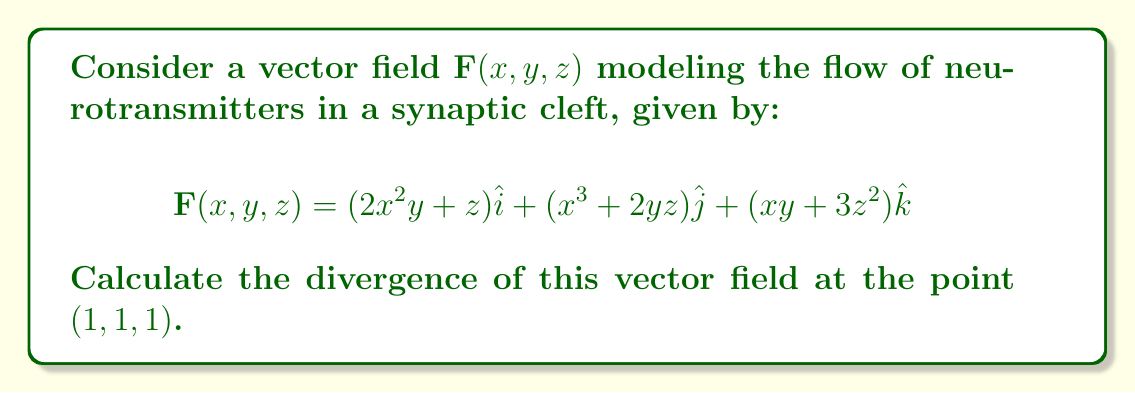Give your solution to this math problem. To calculate the divergence of the vector field $\mathbf{F}(x,y,z)$, we need to use the divergence formula in Cartesian coordinates:

$$\text{div}\,\mathbf{F} = \nabla \cdot \mathbf{F} = \frac{\partial F_x}{\partial x} + \frac{\partial F_y}{\partial y} + \frac{\partial F_z}{\partial z}$$

Let's break it down step-by-step:

1) First, identify the components of $\mathbf{F}$:
   $F_x = 2x^2y + z$
   $F_y = x^3 + 2yz$
   $F_z = xy + 3z^2$

2) Calculate the partial derivatives:
   $\frac{\partial F_x}{\partial x} = 4xy$
   $\frac{\partial F_y}{\partial y} = 2z$
   $\frac{\partial F_z}{\partial z} = 6z$

3) Sum these partial derivatives:
   $\text{div}\,\mathbf{F} = 4xy + 2z + 6z = 4xy + 8z$

4) Evaluate at the point $(1, 1, 1)$:
   $\text{div}\,\mathbf{F}(1,1,1) = 4(1)(1) + 8(1) = 4 + 8 = 12$

Therefore, the divergence of the vector field at the point $(1, 1, 1)$ is 12.
Answer: $12$ 